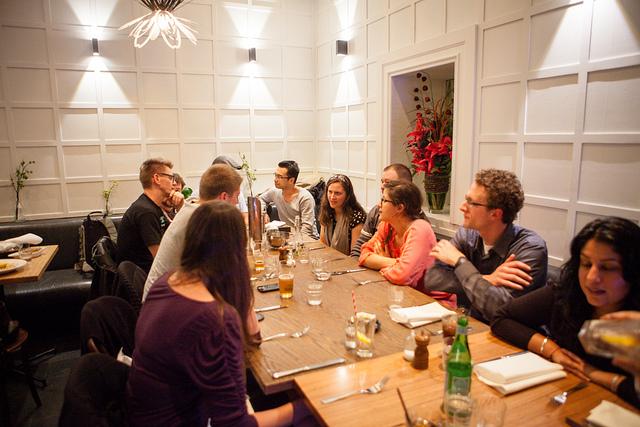Is this family playing a game?
Answer briefly. No. Are the lights on?
Give a very brief answer. Yes. What color are the walls?
Keep it brief. White. How many people are there?
Short answer required. 11. What is the setting of this picture?
Write a very short answer. Restaurant. 